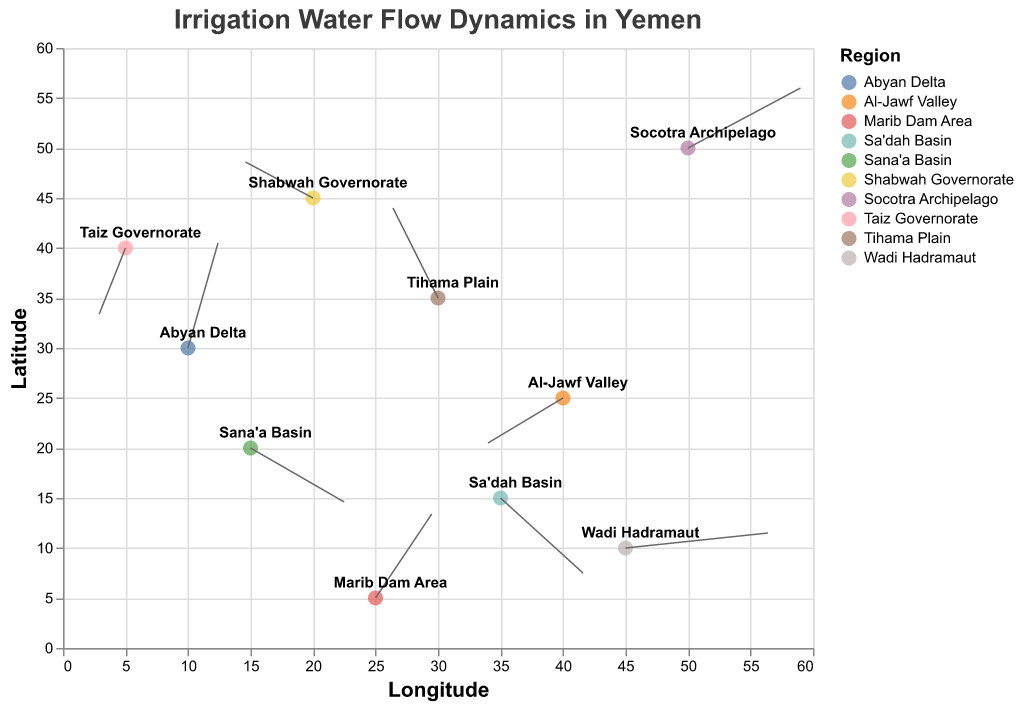What is the title of the plot? The title of the plot can be found at the top of the figure. It provides a brief description of what the plot represents.
Answer: Irrigation Water Flow Dynamics in Yemen What do the `x` and `y` axes represent in this plot? The labels on the axes indicate what they represent. The x-axis represents Longitude, and the y-axis represents Latitude.
Answer: Longitude and Latitude Which region shows the highest positive "u" value, indicating the strongest flow in the x-direction? To find the region with the highest positive "u" value, look at the arrows and identify which one is longest in the horizontal direction. The region with u = 3.8 has the strongest flow.
Answer: Wadi Hadramaut Which region has water flowing towards the southwest? To identify water flowing towards the southwest, find the regions where the u and v values are both negative. The region with negative values for both coordinates indicates southwest flow.
Answer: Taiz Governorate Compare the water flow dynamics between Tihama Plain and Sa'dah Basin. Which region has a stronger vertical component (v-direction) of water flow? To compare the vertical flow component, look at the v-values for both regions: Tihama Plain (v=3.0) and Sa'dah Basin (v=-2.5). The larger absolute value indicates stronger vertical component.
Answer: Tihama Plain Which regions have water flow dynamics with both positive x and positive y components? Regions with positive u and v values indicate water flowing northeast. Sum up the positive u and v points. The corresponding regions are Marib Dam Area and Socotra Archipelago.
Answer: Marib Dam Area, Socotra Archipelago How does the direction of water flow in Al-Jawf Valley compare to that in Sana'a Basin? For comparison, examine both the u and v values of each region. Al-Jawf Valley has u=-2.0 and v=-1.5, indicating a southwest flow, whereas Sana'a Basin has u=2.5 and v=-1.8, indicating a southeast flow.
Answer: Al-Jawf Valley is southwest; Sana'a Basin is southeast Which region displays the lowest vertical water flow component, and what is its value? Look for the smallest v value within the dataset, corresponding to the region with the lowest vertical component.
Answer: Sa'dah Basin, v=-2.5 Which regions have water flows that are primarily horizontal? Identify regions where the absolute value of u is significantly larger than the absolute value of v, indicating predominant horizontal flow.
Answer: Wadi Hadramaut, Sana'a Basin, Sa'dah Basin If you were to focus on regions with declining water flow rates, which two regions would you prioritize based on their negative x and y components? Prioritizing regions by negative u and v values to indicate decline in both directions points to Taiz Governorate and Al-Jawf Valley.
Answer: Taiz Governorate, Al-Jawf Valley 